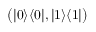Convert formula to latex. <formula><loc_0><loc_0><loc_500><loc_500>{ \left ( } | 0 \rangle \langle 0 | , | 1 \rangle \langle 1 | { \right ) }</formula> 